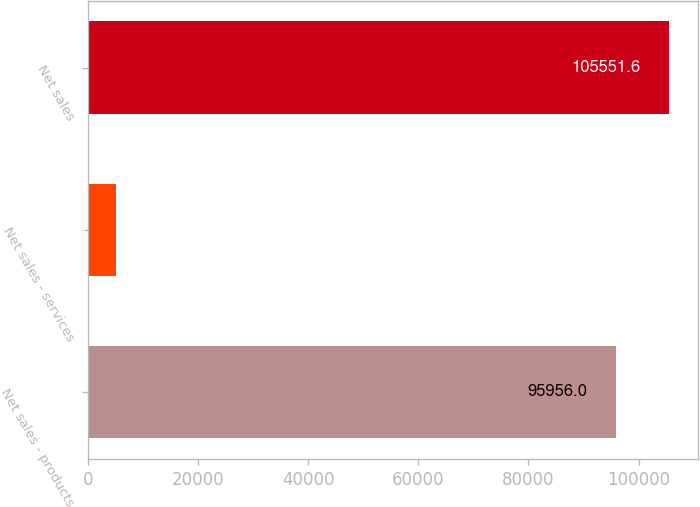<chart> <loc_0><loc_0><loc_500><loc_500><bar_chart><fcel>Net sales - products<fcel>Net sales - services<fcel>Net sales<nl><fcel>95956<fcel>4948<fcel>105552<nl></chart> 